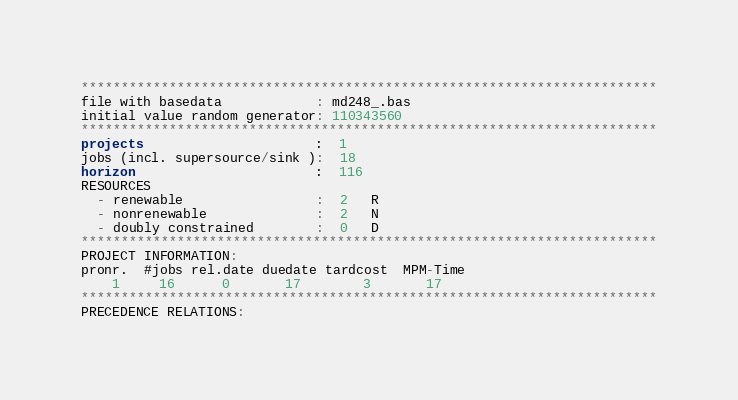<code> <loc_0><loc_0><loc_500><loc_500><_ObjectiveC_>************************************************************************
file with basedata            : md248_.bas
initial value random generator: 110343560
************************************************************************
projects                      :  1
jobs (incl. supersource/sink ):  18
horizon                       :  116
RESOURCES
  - renewable                 :  2   R
  - nonrenewable              :  2   N
  - doubly constrained        :  0   D
************************************************************************
PROJECT INFORMATION:
pronr.  #jobs rel.date duedate tardcost  MPM-Time
    1     16      0       17        3       17
************************************************************************
PRECEDENCE RELATIONS:</code> 